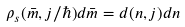<formula> <loc_0><loc_0><loc_500><loc_500>\rho _ { s } ( \bar { m } , j / \hbar { ) } d \bar { m } = d ( n , j ) d n</formula> 